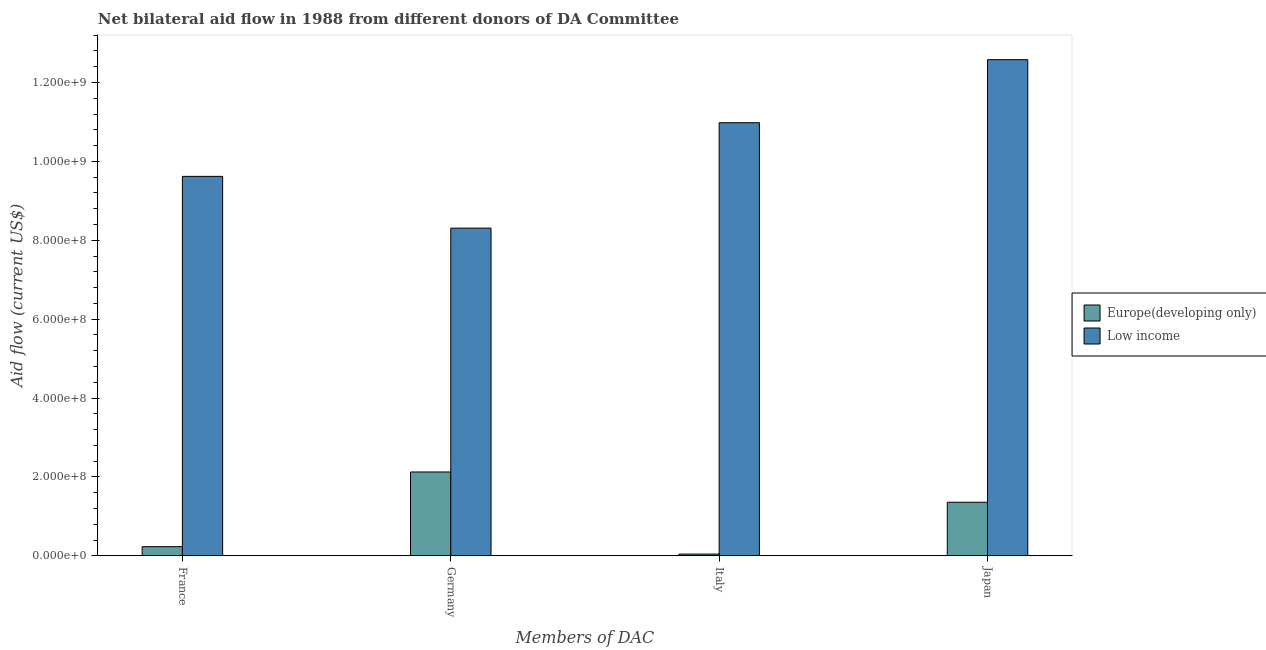How many different coloured bars are there?
Keep it short and to the point. 2. How many groups of bars are there?
Keep it short and to the point. 4. Are the number of bars on each tick of the X-axis equal?
Your response must be concise. Yes. How many bars are there on the 3rd tick from the right?
Your answer should be very brief. 2. What is the label of the 4th group of bars from the left?
Provide a succinct answer. Japan. What is the amount of aid given by italy in Low income?
Your answer should be compact. 1.10e+09. Across all countries, what is the maximum amount of aid given by germany?
Offer a terse response. 8.31e+08. Across all countries, what is the minimum amount of aid given by japan?
Provide a short and direct response. 1.36e+08. In which country was the amount of aid given by japan maximum?
Your answer should be compact. Low income. In which country was the amount of aid given by germany minimum?
Offer a terse response. Europe(developing only). What is the total amount of aid given by france in the graph?
Provide a succinct answer. 9.85e+08. What is the difference between the amount of aid given by italy in Europe(developing only) and that in Low income?
Ensure brevity in your answer.  -1.09e+09. What is the difference between the amount of aid given by japan in Europe(developing only) and the amount of aid given by germany in Low income?
Offer a very short reply. -6.95e+08. What is the average amount of aid given by france per country?
Offer a terse response. 4.93e+08. What is the difference between the amount of aid given by germany and amount of aid given by italy in Low income?
Make the answer very short. -2.67e+08. What is the ratio of the amount of aid given by japan in Europe(developing only) to that in Low income?
Your answer should be very brief. 0.11. Is the difference between the amount of aid given by france in Europe(developing only) and Low income greater than the difference between the amount of aid given by germany in Europe(developing only) and Low income?
Offer a terse response. No. What is the difference between the highest and the second highest amount of aid given by germany?
Give a very brief answer. 6.18e+08. What is the difference between the highest and the lowest amount of aid given by germany?
Provide a succinct answer. 6.18e+08. In how many countries, is the amount of aid given by italy greater than the average amount of aid given by italy taken over all countries?
Ensure brevity in your answer.  1. Is it the case that in every country, the sum of the amount of aid given by italy and amount of aid given by germany is greater than the sum of amount of aid given by france and amount of aid given by japan?
Your answer should be compact. No. What does the 1st bar from the left in Germany represents?
Give a very brief answer. Europe(developing only). What is the difference between two consecutive major ticks on the Y-axis?
Make the answer very short. 2.00e+08. Does the graph contain grids?
Offer a very short reply. No. How many legend labels are there?
Your answer should be compact. 2. What is the title of the graph?
Your answer should be compact. Net bilateral aid flow in 1988 from different donors of DA Committee. Does "High income: OECD" appear as one of the legend labels in the graph?
Your response must be concise. No. What is the label or title of the X-axis?
Your answer should be very brief. Members of DAC. What is the label or title of the Y-axis?
Provide a short and direct response. Aid flow (current US$). What is the Aid flow (current US$) in Europe(developing only) in France?
Make the answer very short. 2.32e+07. What is the Aid flow (current US$) of Low income in France?
Make the answer very short. 9.62e+08. What is the Aid flow (current US$) in Europe(developing only) in Germany?
Your response must be concise. 2.12e+08. What is the Aid flow (current US$) in Low income in Germany?
Give a very brief answer. 8.31e+08. What is the Aid flow (current US$) of Europe(developing only) in Italy?
Ensure brevity in your answer.  4.34e+06. What is the Aid flow (current US$) of Low income in Italy?
Make the answer very short. 1.10e+09. What is the Aid flow (current US$) in Europe(developing only) in Japan?
Your answer should be compact. 1.36e+08. What is the Aid flow (current US$) in Low income in Japan?
Your response must be concise. 1.26e+09. Across all Members of DAC, what is the maximum Aid flow (current US$) in Europe(developing only)?
Keep it short and to the point. 2.12e+08. Across all Members of DAC, what is the maximum Aid flow (current US$) in Low income?
Provide a short and direct response. 1.26e+09. Across all Members of DAC, what is the minimum Aid flow (current US$) in Europe(developing only)?
Make the answer very short. 4.34e+06. Across all Members of DAC, what is the minimum Aid flow (current US$) in Low income?
Your response must be concise. 8.31e+08. What is the total Aid flow (current US$) in Europe(developing only) in the graph?
Ensure brevity in your answer.  3.76e+08. What is the total Aid flow (current US$) of Low income in the graph?
Ensure brevity in your answer.  4.15e+09. What is the difference between the Aid flow (current US$) of Europe(developing only) in France and that in Germany?
Offer a very short reply. -1.89e+08. What is the difference between the Aid flow (current US$) in Low income in France and that in Germany?
Provide a succinct answer. 1.31e+08. What is the difference between the Aid flow (current US$) of Europe(developing only) in France and that in Italy?
Provide a short and direct response. 1.88e+07. What is the difference between the Aid flow (current US$) of Low income in France and that in Italy?
Provide a succinct answer. -1.36e+08. What is the difference between the Aid flow (current US$) of Europe(developing only) in France and that in Japan?
Give a very brief answer. -1.13e+08. What is the difference between the Aid flow (current US$) of Low income in France and that in Japan?
Give a very brief answer. -2.96e+08. What is the difference between the Aid flow (current US$) in Europe(developing only) in Germany and that in Italy?
Provide a short and direct response. 2.08e+08. What is the difference between the Aid flow (current US$) of Low income in Germany and that in Italy?
Make the answer very short. -2.67e+08. What is the difference between the Aid flow (current US$) in Europe(developing only) in Germany and that in Japan?
Your answer should be compact. 7.67e+07. What is the difference between the Aid flow (current US$) of Low income in Germany and that in Japan?
Your answer should be compact. -4.27e+08. What is the difference between the Aid flow (current US$) in Europe(developing only) in Italy and that in Japan?
Your answer should be very brief. -1.31e+08. What is the difference between the Aid flow (current US$) in Low income in Italy and that in Japan?
Your answer should be compact. -1.60e+08. What is the difference between the Aid flow (current US$) in Europe(developing only) in France and the Aid flow (current US$) in Low income in Germany?
Your answer should be very brief. -8.08e+08. What is the difference between the Aid flow (current US$) of Europe(developing only) in France and the Aid flow (current US$) of Low income in Italy?
Offer a terse response. -1.07e+09. What is the difference between the Aid flow (current US$) in Europe(developing only) in France and the Aid flow (current US$) in Low income in Japan?
Ensure brevity in your answer.  -1.23e+09. What is the difference between the Aid flow (current US$) in Europe(developing only) in Germany and the Aid flow (current US$) in Low income in Italy?
Your answer should be very brief. -8.86e+08. What is the difference between the Aid flow (current US$) of Europe(developing only) in Germany and the Aid flow (current US$) of Low income in Japan?
Offer a very short reply. -1.05e+09. What is the difference between the Aid flow (current US$) of Europe(developing only) in Italy and the Aid flow (current US$) of Low income in Japan?
Your answer should be compact. -1.25e+09. What is the average Aid flow (current US$) in Europe(developing only) per Members of DAC?
Give a very brief answer. 9.39e+07. What is the average Aid flow (current US$) in Low income per Members of DAC?
Offer a very short reply. 1.04e+09. What is the difference between the Aid flow (current US$) in Europe(developing only) and Aid flow (current US$) in Low income in France?
Provide a succinct answer. -9.39e+08. What is the difference between the Aid flow (current US$) of Europe(developing only) and Aid flow (current US$) of Low income in Germany?
Give a very brief answer. -6.18e+08. What is the difference between the Aid flow (current US$) of Europe(developing only) and Aid flow (current US$) of Low income in Italy?
Your answer should be compact. -1.09e+09. What is the difference between the Aid flow (current US$) in Europe(developing only) and Aid flow (current US$) in Low income in Japan?
Offer a terse response. -1.12e+09. What is the ratio of the Aid flow (current US$) in Europe(developing only) in France to that in Germany?
Provide a short and direct response. 0.11. What is the ratio of the Aid flow (current US$) of Low income in France to that in Germany?
Ensure brevity in your answer.  1.16. What is the ratio of the Aid flow (current US$) in Europe(developing only) in France to that in Italy?
Your answer should be compact. 5.34. What is the ratio of the Aid flow (current US$) in Low income in France to that in Italy?
Offer a very short reply. 0.88. What is the ratio of the Aid flow (current US$) in Europe(developing only) in France to that in Japan?
Provide a short and direct response. 0.17. What is the ratio of the Aid flow (current US$) in Low income in France to that in Japan?
Ensure brevity in your answer.  0.76. What is the ratio of the Aid flow (current US$) of Europe(developing only) in Germany to that in Italy?
Give a very brief answer. 48.96. What is the ratio of the Aid flow (current US$) of Low income in Germany to that in Italy?
Provide a succinct answer. 0.76. What is the ratio of the Aid flow (current US$) in Europe(developing only) in Germany to that in Japan?
Your answer should be very brief. 1.57. What is the ratio of the Aid flow (current US$) in Low income in Germany to that in Japan?
Your answer should be very brief. 0.66. What is the ratio of the Aid flow (current US$) in Europe(developing only) in Italy to that in Japan?
Provide a succinct answer. 0.03. What is the ratio of the Aid flow (current US$) in Low income in Italy to that in Japan?
Offer a terse response. 0.87. What is the difference between the highest and the second highest Aid flow (current US$) in Europe(developing only)?
Make the answer very short. 7.67e+07. What is the difference between the highest and the second highest Aid flow (current US$) of Low income?
Offer a terse response. 1.60e+08. What is the difference between the highest and the lowest Aid flow (current US$) of Europe(developing only)?
Offer a very short reply. 2.08e+08. What is the difference between the highest and the lowest Aid flow (current US$) in Low income?
Provide a succinct answer. 4.27e+08. 